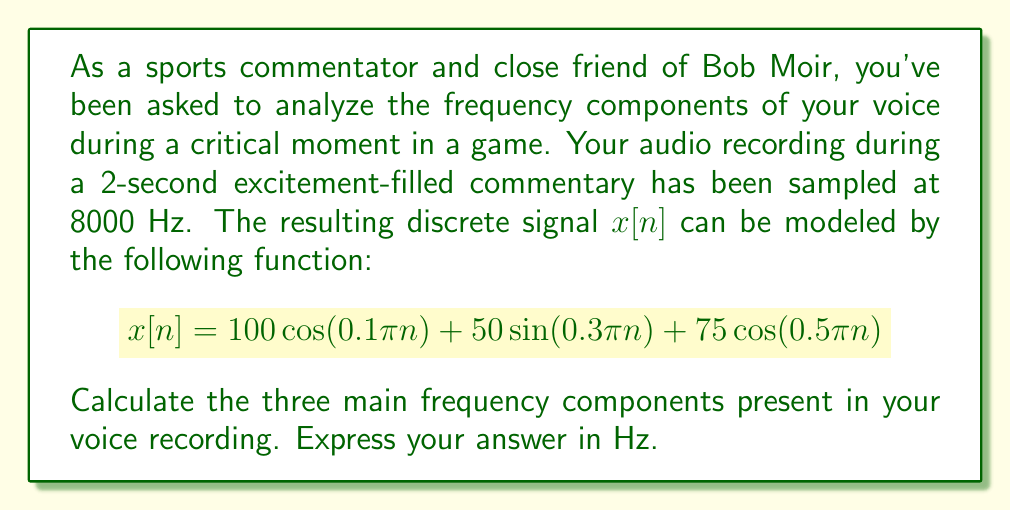Could you help me with this problem? To find the frequency components, we need to convert the discrete-time frequencies in the given function to continuous-time frequencies. We'll follow these steps:

1) The general formula to convert from discrete-time frequency $\omega$ (in radians/sample) to continuous-time frequency $f$ (in Hz) is:

   $$f = \frac{\omega F_s}{2\pi}$$

   where $F_s$ is the sampling frequency (8000 Hz in this case).

2) We have three components in the signal:
   a) $\cos(0.1\pi n)$
   b) $\sin(0.3\pi n)$
   c) $\cos(0.5\pi n)$

3) Let's calculate each frequency:

   a) For $\cos(0.1\pi n)$:
      $\omega_1 = 0.1\pi$
      $f_1 = \frac{0.1\pi \cdot 8000}{2\pi} = 400$ Hz

   b) For $\sin(0.3\pi n)$:
      $\omega_2 = 0.3\pi$
      $f_2 = \frac{0.3\pi \cdot 8000}{2\pi} = 1200$ Hz

   c) For $\cos(0.5\pi n)$:
      $\omega_3 = 0.5\pi$
      $f_3 = \frac{0.5\pi \cdot 8000}{2\pi} = 2000$ Hz

Therefore, the three main frequency components in your voice recording are 400 Hz, 1200 Hz, and 2000 Hz.
Answer: 400 Hz, 1200 Hz, 2000 Hz 